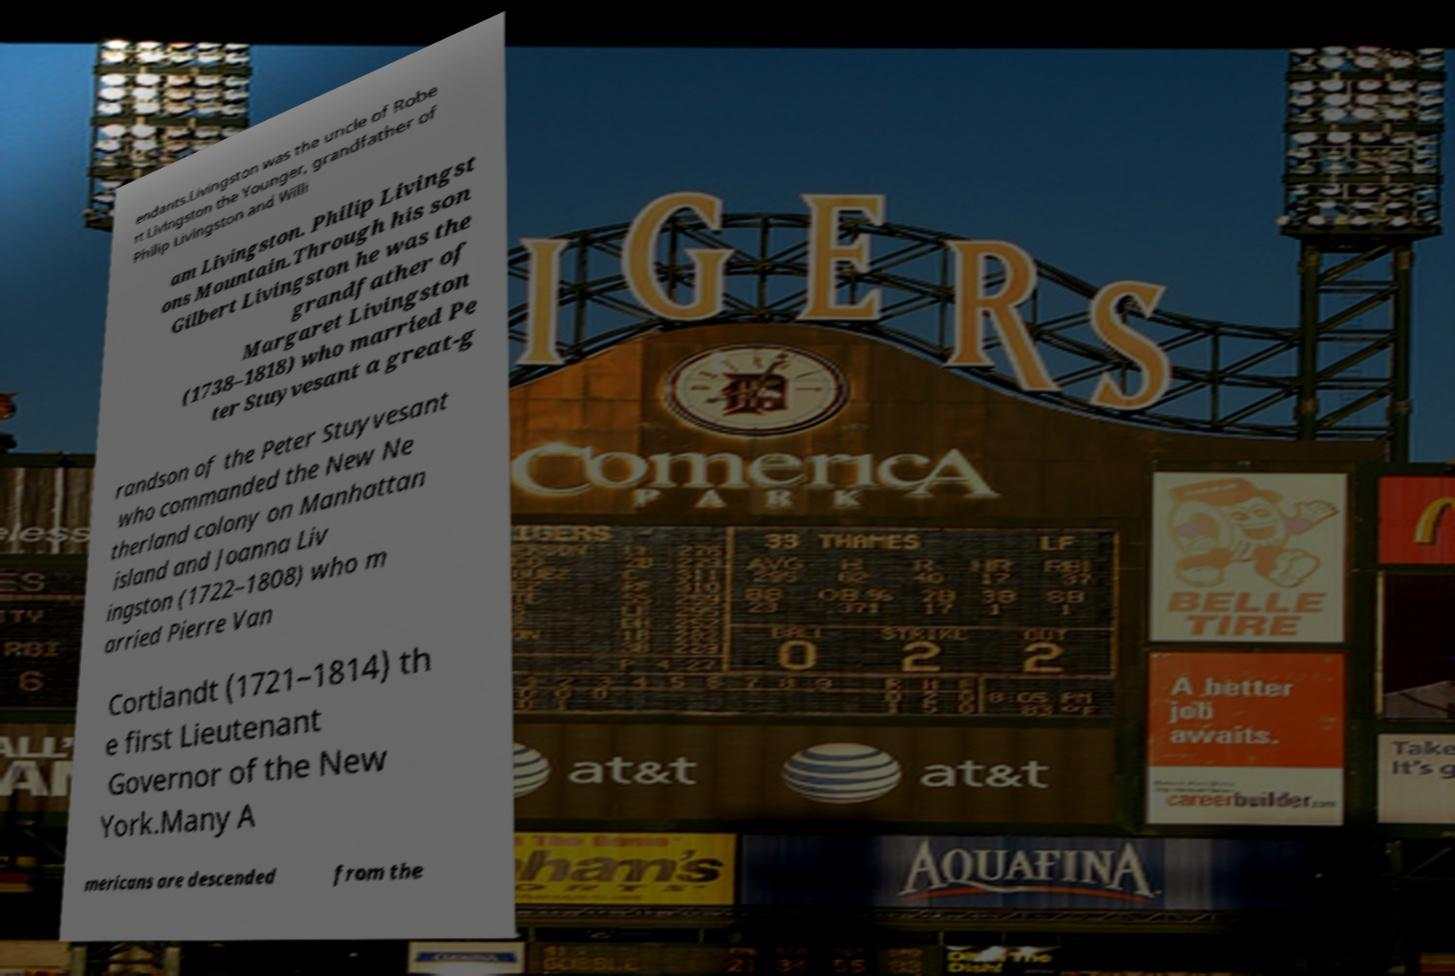What messages or text are displayed in this image? I need them in a readable, typed format. endants.Livingston was the uncle of Robe rt Livingston the Younger, grandfather of Philip Livingston and Willi am Livingston. Philip Livingst ons Mountain.Through his son Gilbert Livingston he was the grandfather of Margaret Livingston (1738–1818) who married Pe ter Stuyvesant a great-g randson of the Peter Stuyvesant who commanded the New Ne therland colony on Manhattan island and Joanna Liv ingston (1722–1808) who m arried Pierre Van Cortlandt (1721–1814) th e first Lieutenant Governor of the New York.Many A mericans are descended from the 